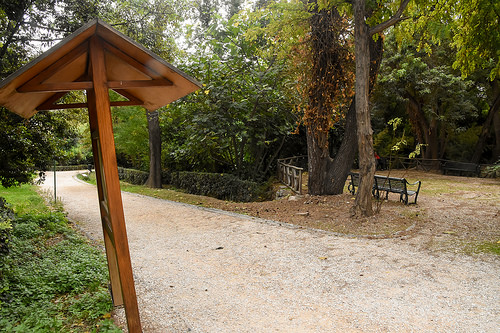<image>
Is the tree above the land? No. The tree is not positioned above the land. The vertical arrangement shows a different relationship. 